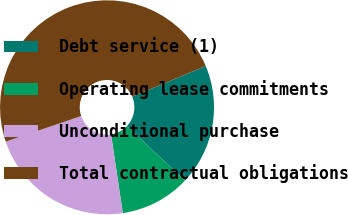Convert chart. <chart><loc_0><loc_0><loc_500><loc_500><pie_chart><fcel>Debt service (1)<fcel>Operating lease commitments<fcel>Unconditional purchase<fcel>Total contractual obligations<nl><fcel>18.32%<fcel>10.64%<fcel>22.15%<fcel>48.89%<nl></chart> 